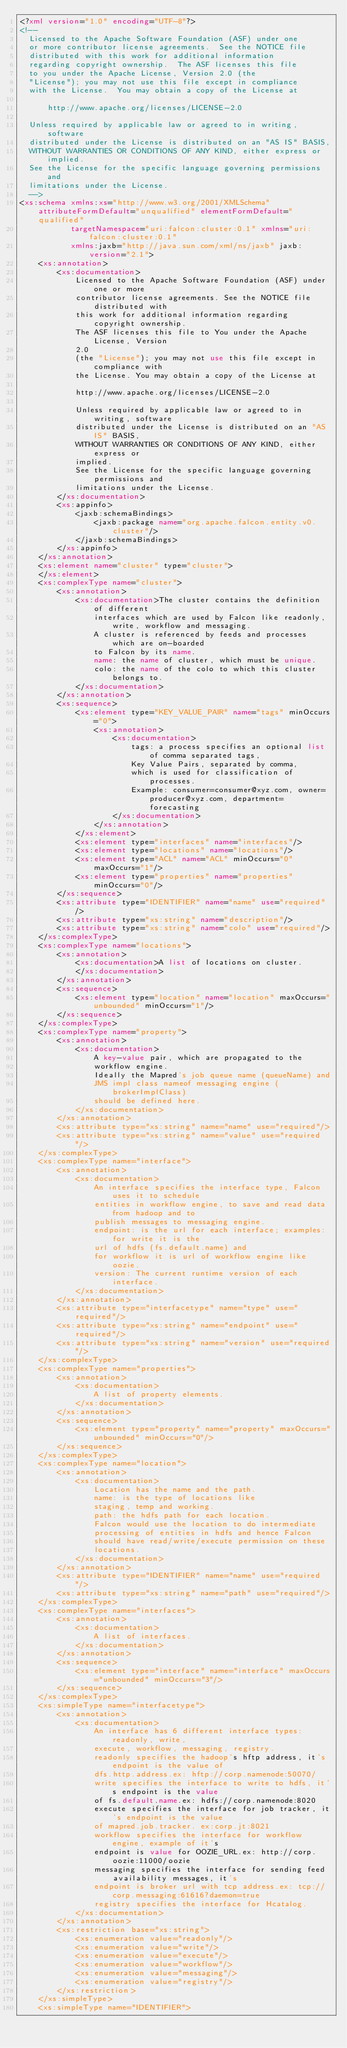<code> <loc_0><loc_0><loc_500><loc_500><_XML_><?xml version="1.0" encoding="UTF-8"?>
<!--
  Licensed to the Apache Software Foundation (ASF) under one
  or more contributor license agreements.  See the NOTICE file
  distributed with this work for additional information
  regarding copyright ownership.  The ASF licenses this file
  to you under the Apache License, Version 2.0 (the
  "License"); you may not use this file except in compliance
  with the License.  You may obtain a copy of the License at

      http://www.apache.org/licenses/LICENSE-2.0

  Unless required by applicable law or agreed to in writing, software
  distributed under the License is distributed on an "AS IS" BASIS,
  WITHOUT WARRANTIES OR CONDITIONS OF ANY KIND, either express or implied.
  See the License for the specific language governing permissions and
  limitations under the License.
  -->
<xs:schema xmlns:xs="http://www.w3.org/2001/XMLSchema" attributeFormDefault="unqualified" elementFormDefault="qualified"
           targetNamespace="uri:falcon:cluster:0.1" xmlns="uri:falcon:cluster:0.1"
           xmlns:jaxb="http://java.sun.com/xml/ns/jaxb" jaxb:version="2.1">
    <xs:annotation>
        <xs:documentation>
            Licensed to the Apache Software Foundation (ASF) under one or more
            contributor license agreements. See the NOTICE file distributed with
            this work for additional information regarding copyright ownership.
            The ASF licenses this file to You under the Apache License, Version
            2.0
            (the "License"); you may not use this file except in compliance with
            the License. You may obtain a copy of the License at

            http://www.apache.org/licenses/LICENSE-2.0

            Unless required by applicable law or agreed to in writing, software
            distributed under the License is distributed on an "AS IS" BASIS,
            WITHOUT WARRANTIES OR CONDITIONS OF ANY KIND, either express or
            implied.
            See the License for the specific language governing permissions and
            limitations under the License.
        </xs:documentation>
        <xs:appinfo>
            <jaxb:schemaBindings>
                <jaxb:package name="org.apache.falcon.entity.v0.cluster"/>
            </jaxb:schemaBindings>
        </xs:appinfo>
    </xs:annotation>
    <xs:element name="cluster" type="cluster">
    </xs:element>
    <xs:complexType name="cluster">
        <xs:annotation>
            <xs:documentation>The cluster contains the definition of different
                interfaces which are used by Falcon like readonly, write, workflow and messaging.
                A cluster is referenced by feeds and processes which are on-boarded
                to Falcon by its name.
                name: the name of cluster, which must be unique.
                colo: the name of the colo to which this cluster belongs to.
            </xs:documentation>
        </xs:annotation>
        <xs:sequence>
            <xs:element type="KEY_VALUE_PAIR" name="tags" minOccurs="0">
                <xs:annotation>
                    <xs:documentation>
                        tags: a process specifies an optional list of comma separated tags,
                        Key Value Pairs, separated by comma,
                        which is used for classification of processes.
                        Example: consumer=consumer@xyz.com, owner=producer@xyz.com, department=forecasting
                    </xs:documentation>
                </xs:annotation>
            </xs:element>
            <xs:element type="interfaces" name="interfaces"/>
            <xs:element type="locations" name="locations"/>
            <xs:element type="ACL" name="ACL" minOccurs="0" maxOccurs="1"/>
            <xs:element type="properties" name="properties" minOccurs="0"/>
        </xs:sequence>
        <xs:attribute type="IDENTIFIER" name="name" use="required"/>
        <xs:attribute type="xs:string" name="description"/>
        <xs:attribute type="xs:string" name="colo" use="required"/>
    </xs:complexType>
    <xs:complexType name="locations">
        <xs:annotation>
            <xs:documentation>A list of locations on cluster.
            </xs:documentation>
        </xs:annotation>
        <xs:sequence>
            <xs:element type="location" name="location" maxOccurs="unbounded" minOccurs="1"/>
        </xs:sequence>
    </xs:complexType>
    <xs:complexType name="property">
        <xs:annotation>
            <xs:documentation>
                A key-value pair, which are propagated to the
                workflow engine.
                Ideally the Mapred's job queue name (queueName) and
                JMS impl class nameof messaging engine (brokerImplClass)
                should be defined here.
            </xs:documentation>
        </xs:annotation>
        <xs:attribute type="xs:string" name="name" use="required"/>
        <xs:attribute type="xs:string" name="value" use="required"/>
    </xs:complexType>
    <xs:complexType name="interface">
        <xs:annotation>
            <xs:documentation>
                An interface specifies the interface type, Falcon uses it to schedule
                entities in workflow engine, to save and read data from hadoop and to
                publish messages to messaging engine.
                endpoint: is the url for each interface; examples: for write it is the
                url of hdfs (fs.default.name) and
                for workflow it is url of workflow engine like oozie.
                version: The current runtime version of each interface.
            </xs:documentation>
        </xs:annotation>
        <xs:attribute type="interfacetype" name="type" use="required"/>
        <xs:attribute type="xs:string" name="endpoint" use="required"/>
        <xs:attribute type="xs:string" name="version" use="required"/>
    </xs:complexType>
    <xs:complexType name="properties">
        <xs:annotation>
            <xs:documentation>
                A list of property elements.
            </xs:documentation>
        </xs:annotation>
        <xs:sequence>
            <xs:element type="property" name="property" maxOccurs="unbounded" minOccurs="0"/>
        </xs:sequence>
    </xs:complexType>
    <xs:complexType name="location">
        <xs:annotation>
            <xs:documentation>
                Location has the name and the path.
                name: is the type of locations like
                staging, temp and working.
                path: the hdfs path for each location.
                Falcon would use the location to do intermediate
                processing of entities in hdfs and hence Falcon
                should have read/write/execute permission on these
                locations.
            </xs:documentation>
        </xs:annotation>
        <xs:attribute type="IDENTIFIER" name="name" use="required"/>
        <xs:attribute type="xs:string" name="path" use="required"/>
    </xs:complexType>
    <xs:complexType name="interfaces">
        <xs:annotation>
            <xs:documentation>
                A list of interfaces.
            </xs:documentation>
        </xs:annotation>
        <xs:sequence>
            <xs:element type="interface" name="interface" maxOccurs="unbounded" minOccurs="3"/>
        </xs:sequence>
    </xs:complexType>
    <xs:simpleType name="interfacetype">
        <xs:annotation>
            <xs:documentation>
                An interface has 6 different interface types: readonly, write,
                execute, workflow, messaging, registry.
                readonly specifies the hadoop's hftp address, it's endpoint is the value of
                dfs.http.address.ex: hftp://corp.namenode:50070/
                write specifies the interface to write to hdfs, it's endpoint is the value
                of fs.default.name.ex: hdfs://corp.namenode:8020
                execute specifies the interface for job tracker, it's endpoint is the value
                of mapred.job.tracker. ex:corp.jt:8021
                workflow specifies the interface for workflow engine, example of it's
                endpoint is value for OOZIE_URL.ex: http://corp.oozie:11000/oozie
                messaging specifies the interface for sending feed availability messages, it's
                endpoint is broker url with tcp address.ex: tcp://corp.messaging:61616?daemon=true
                registry specifies the interface for Hcatalog.
            </xs:documentation>
        </xs:annotation>
        <xs:restriction base="xs:string">
            <xs:enumeration value="readonly"/>
            <xs:enumeration value="write"/>
            <xs:enumeration value="execute"/>
            <xs:enumeration value="workflow"/>
            <xs:enumeration value="messaging"/>
            <xs:enumeration value="registry"/>
        </xs:restriction>
    </xs:simpleType>
    <xs:simpleType name="IDENTIFIER"></code> 